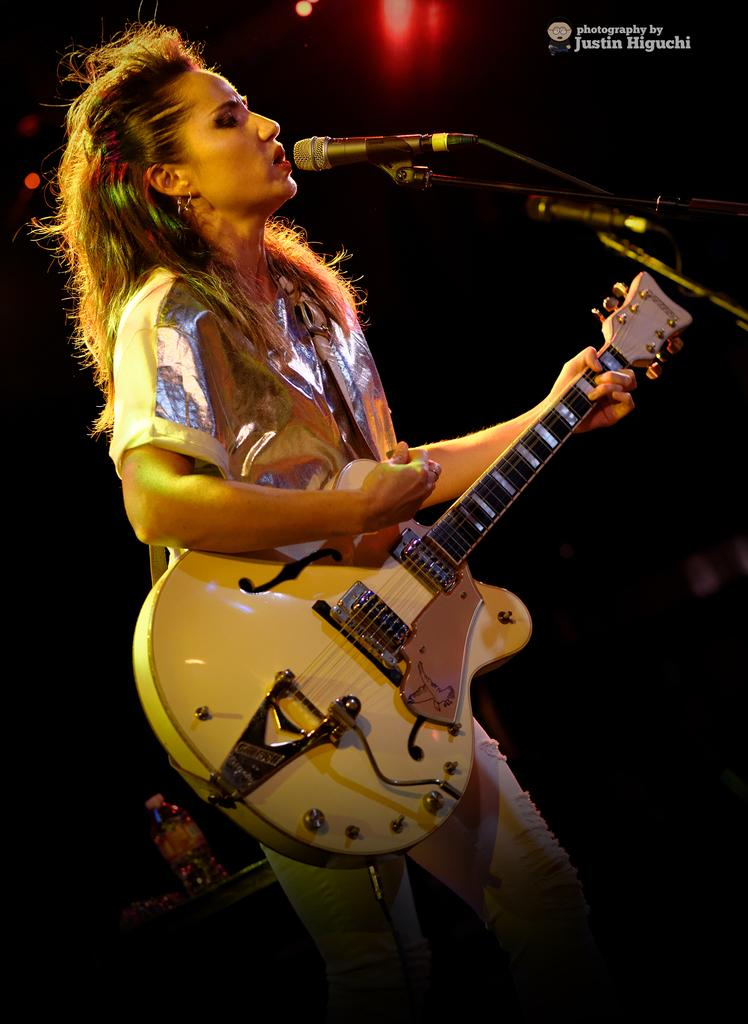Who is present in the image? There is a woman in the image. What is the woman holding in the image? The woman is holding a guitar. What object is associated with singing or speaking in the image? There is a microphone in the image. What can be seen on the right side of the image? There is a watermark on the right side of the image. What type of lighting is visible in the background of the image? Pink lights are visible in the background of the image. How many kittens are being transported in the image? There are no kittens or any form of transportation present in the image. What is the limit of the guitar's capabilities in the image? The image does not provide information about the guitar's capabilities or any limitations. 